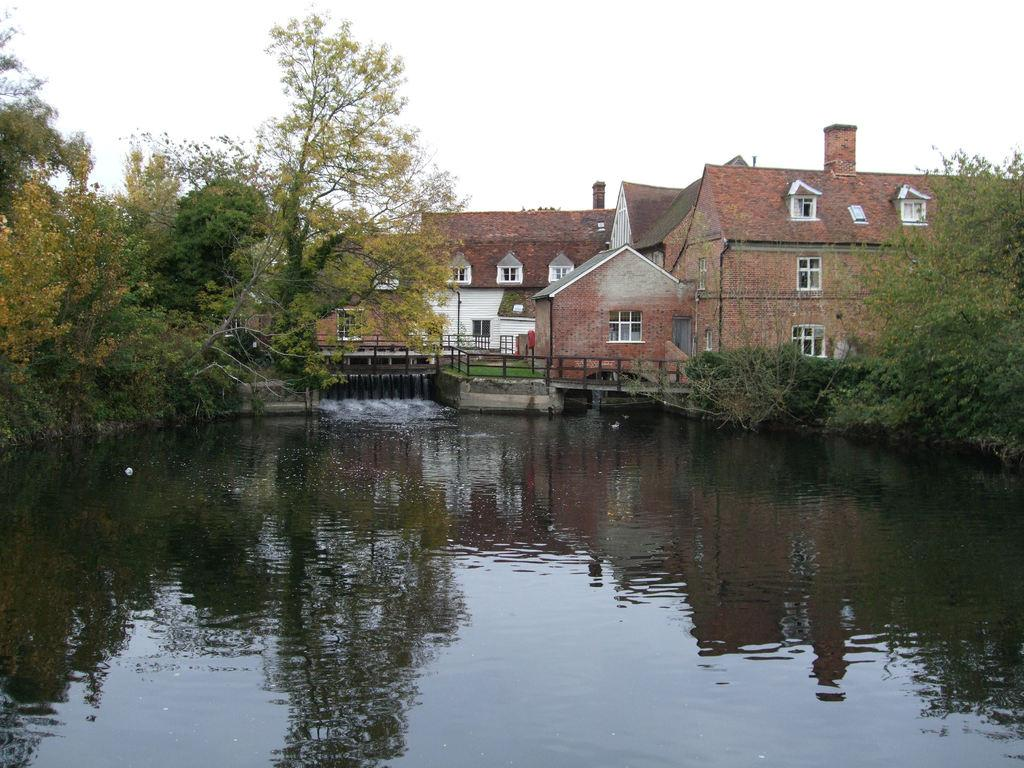What type of structures are visible in the image? There are houses in the image. What feature is common to many of the houses? There are windows in the houses visible in the image. What are the poles used for in the image? The purpose of the poles in the image is not specified, but they could be for various purposes such as lighting or signage. What type of barrier is present in the image? There is fencing in the image. What type of vegetation is visible in the image? There are trees in the image. What natural element is visible in the image? There is water visible in the image. What is the color of the sky in the image? The sky appears to be white in color. What team is observing the side of the house in the image? There is no team present in the image, and no one is observing the side of the house. 